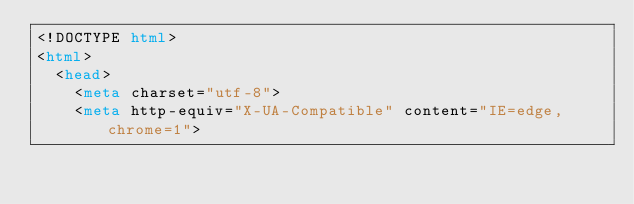Convert code to text. <code><loc_0><loc_0><loc_500><loc_500><_HTML_><!DOCTYPE html>
<html>
  <head>
    <meta charset="utf-8">
    <meta http-equiv="X-UA-Compatible" content="IE=edge,chrome=1"></code> 